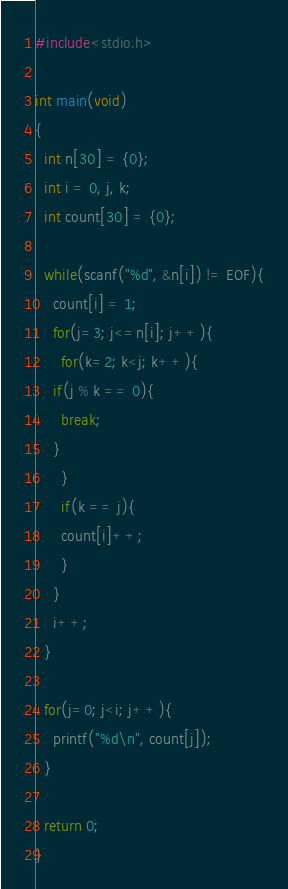<code> <loc_0><loc_0><loc_500><loc_500><_C_>#include<stdio.h>

int main(void)
{
  int n[30] = {0};
  int i = 0, j, k;
  int count[30] = {0};

  while(scanf("%d", &n[i]) != EOF){
    count[i] = 1;
    for(j=3; j<=n[i]; j++){
      for(k=2; k<j; k++){
	if(j % k == 0){
	  break;
	}
      }
      if(k == j){
      count[i]++;
      }
    }
    i++;
  }

  for(j=0; j<i; j++){
    printf("%d\n", count[j]);
  }

  return 0;
}</code> 